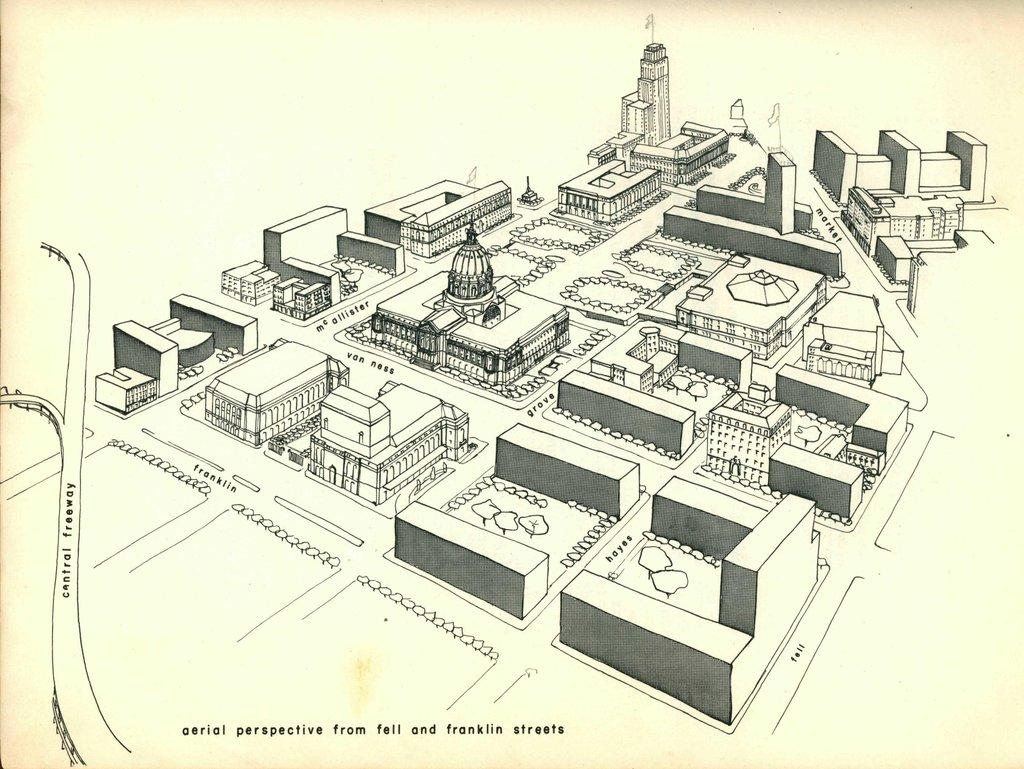What is the main subject of the paper in the image? The paper has a print of many buildings. Is there any text on the paper? Yes, there is writing on the paper. What type of expert can be seen advising on the sink in the image? There is no expert or sink present in the image; it only features a paper with a print of many buildings and writing. 